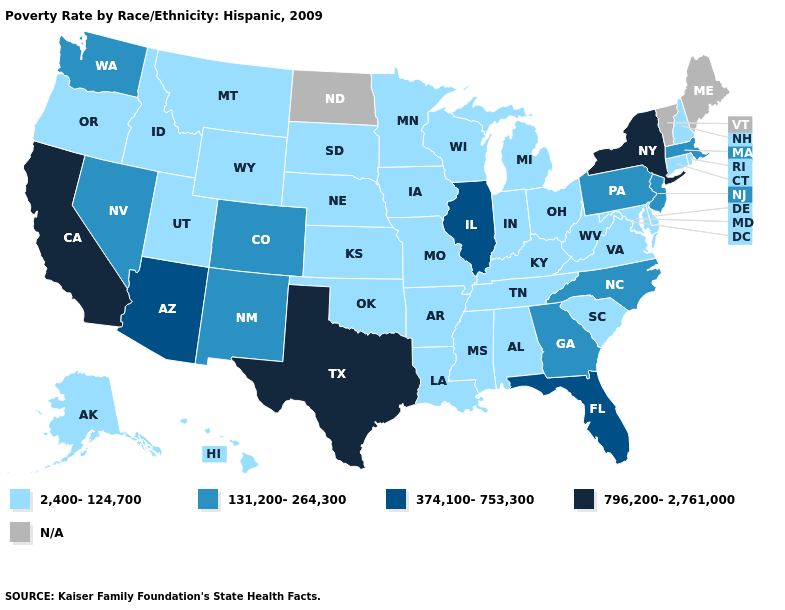Which states have the lowest value in the USA?
Short answer required. Alabama, Alaska, Arkansas, Connecticut, Delaware, Hawaii, Idaho, Indiana, Iowa, Kansas, Kentucky, Louisiana, Maryland, Michigan, Minnesota, Mississippi, Missouri, Montana, Nebraska, New Hampshire, Ohio, Oklahoma, Oregon, Rhode Island, South Carolina, South Dakota, Tennessee, Utah, Virginia, West Virginia, Wisconsin, Wyoming. How many symbols are there in the legend?
Answer briefly. 5. Name the states that have a value in the range 796,200-2,761,000?
Keep it brief. California, New York, Texas. Which states have the highest value in the USA?
Answer briefly. California, New York, Texas. Does California have the highest value in the West?
Write a very short answer. Yes. What is the lowest value in states that border Idaho?
Write a very short answer. 2,400-124,700. Does California have the highest value in the West?
Short answer required. Yes. What is the value of West Virginia?
Quick response, please. 2,400-124,700. Among the states that border New York , does Connecticut have the lowest value?
Short answer required. Yes. Does Texas have the highest value in the South?
Quick response, please. Yes. What is the value of Delaware?
Keep it brief. 2,400-124,700. Among the states that border Arizona , does Nevada have the highest value?
Concise answer only. No. Among the states that border Pennsylvania , does West Virginia have the lowest value?
Keep it brief. Yes. What is the value of Kansas?
Keep it brief. 2,400-124,700. Does Colorado have the lowest value in the West?
Concise answer only. No. 